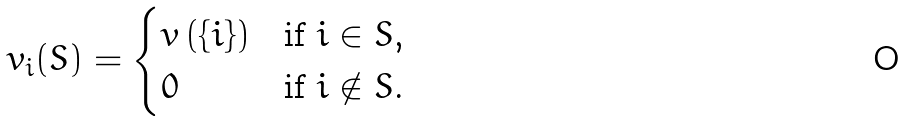Convert formula to latex. <formula><loc_0><loc_0><loc_500><loc_500>v _ { i } ( S ) = \begin{cases} v \left ( \{ i \} \right ) & \text {if $ i \in S $,} \\ 0 & \text {if $ i \notin S $.} \end{cases}</formula> 